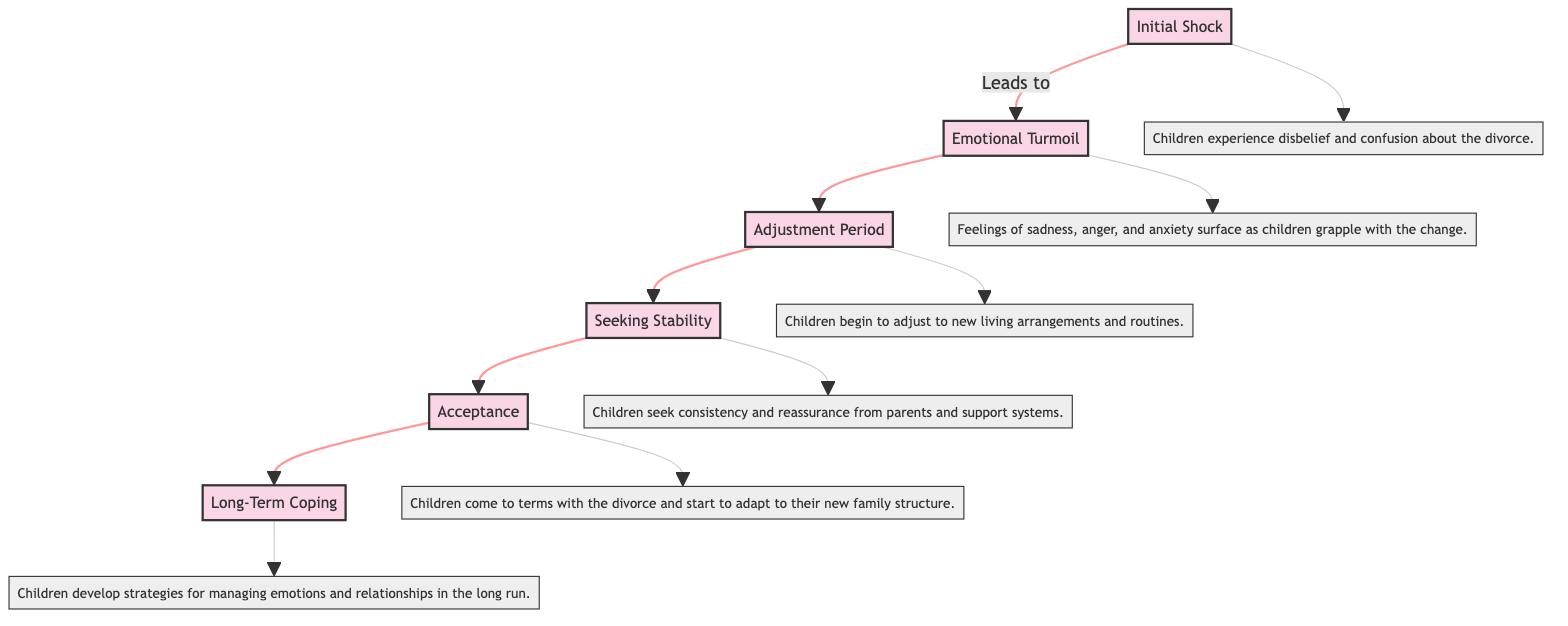What is the first stage of adjustment? The diagram indicates the first stage of adjustment is labeled "Initial Shock." This is confirmed by examining the flow starting point.
Answer: Initial Shock How many stages of adjustment are there in total? The flow chart lists six distinct stages labeled from "Initial Shock" to "Long-Term Coping." By counting each of the stages shown in the diagram, the total is determined to be six.
Answer: 6 What stage comes after "Emotional Turmoil"? The flow chart shows an arrow leading from "Emotional Turmoil" to "Adjustment Period." This direct connection indicates the sequence in the adjustment process.
Answer: Adjustment Period What are children seeking in the "Seeking Stability" stage? Referring to the description associated with the "Seeking Stability" stage reveals that children are looking for "consistency and reassurance from parents and support systems.” This information is explicitly stated in the diagram.
Answer: Consistency and reassurance What is described in the "Acceptance" stage? The chart's description for the "Acceptance" stage notes that children "come to terms with the divorce and start to adapt to their new family structure." This meaning is taken directly from the corresponding explanatory text linked to this stage.
Answer: Come to terms with the divorce Which stage follows after "Acceptance"? The flow chart illustrates that "Long-Term Coping" directly follows "Acceptance," indicating the next step in children's adjustment process after reaching acceptance.
Answer: Long-Term Coping 